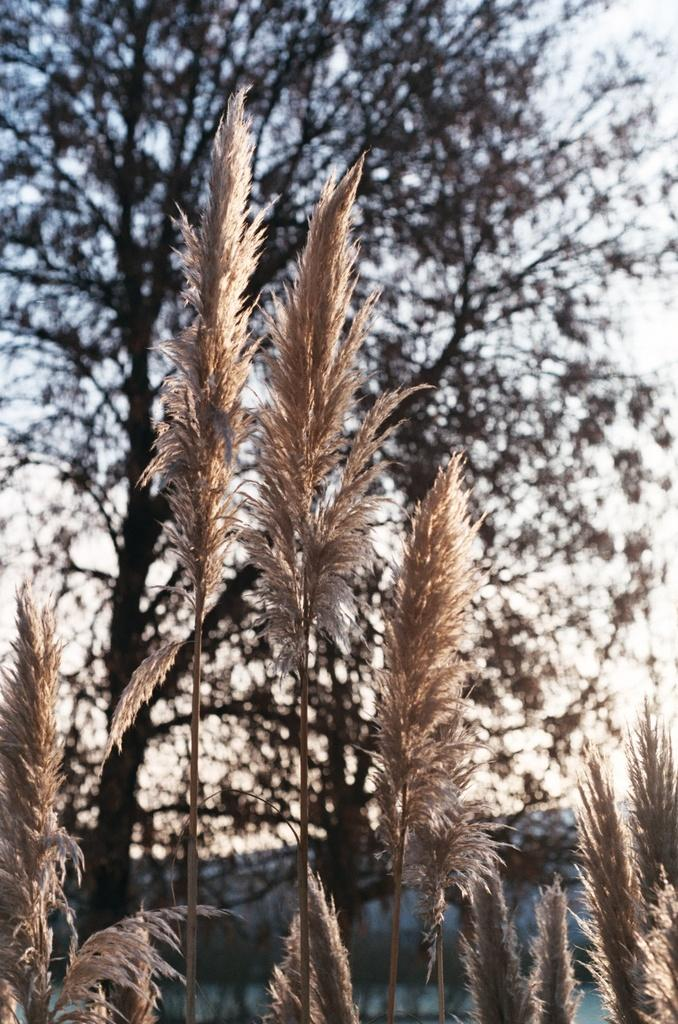What type of living organisms can be seen in the image? Plants and a tree are visible in the image. What part of the natural environment is visible in the image? The sky is visible in the image. What type of bubble can be seen floating in the image? There is no bubble present in the image. What act is the tree performing in the image? Trees do not perform acts; they are stationary plants. 